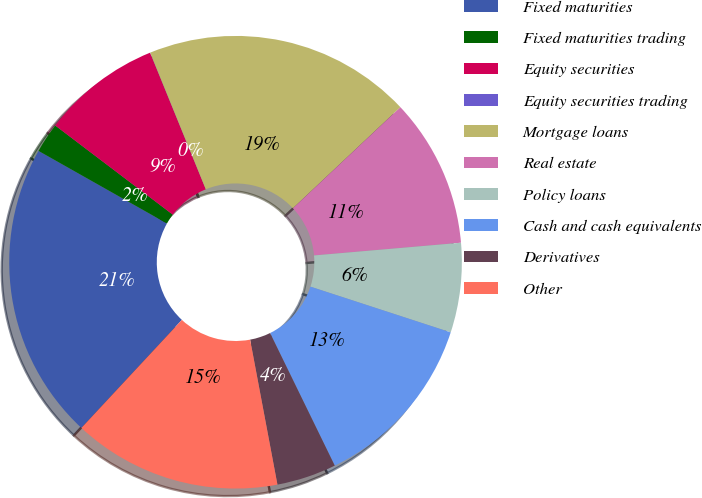Convert chart. <chart><loc_0><loc_0><loc_500><loc_500><pie_chart><fcel>Fixed maturities<fcel>Fixed maturities trading<fcel>Equity securities<fcel>Equity securities trading<fcel>Mortgage loans<fcel>Real estate<fcel>Policy loans<fcel>Cash and cash equivalents<fcel>Derivatives<fcel>Other<nl><fcel>21.26%<fcel>2.14%<fcel>8.51%<fcel>0.01%<fcel>19.14%<fcel>10.64%<fcel>6.39%<fcel>12.76%<fcel>4.26%<fcel>14.89%<nl></chart> 